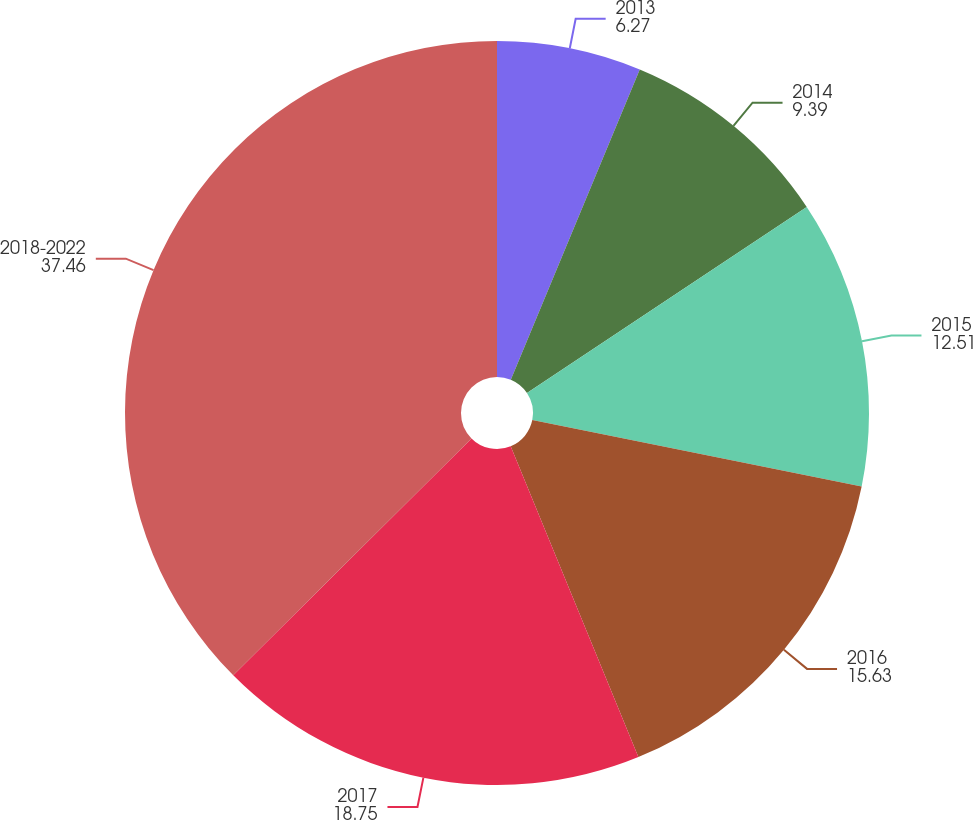<chart> <loc_0><loc_0><loc_500><loc_500><pie_chart><fcel>2013<fcel>2014<fcel>2015<fcel>2016<fcel>2017<fcel>2018-2022<nl><fcel>6.27%<fcel>9.39%<fcel>12.51%<fcel>15.63%<fcel>18.75%<fcel>37.46%<nl></chart> 